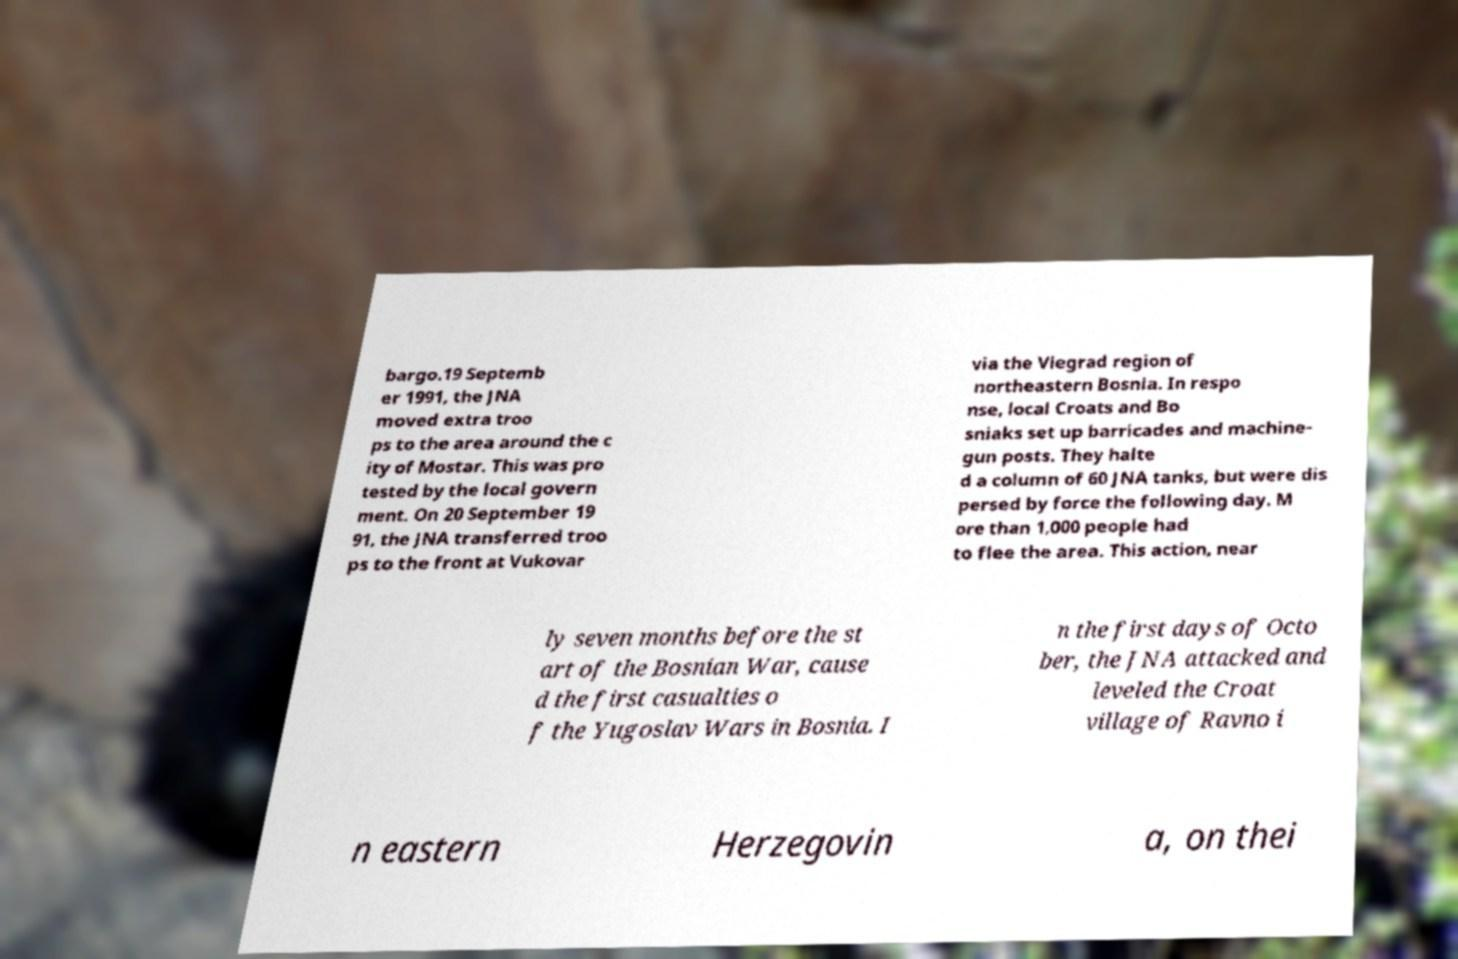Can you read and provide the text displayed in the image?This photo seems to have some interesting text. Can you extract and type it out for me? bargo.19 Septemb er 1991, the JNA moved extra troo ps to the area around the c ity of Mostar. This was pro tested by the local govern ment. On 20 September 19 91, the JNA transferred troo ps to the front at Vukovar via the Viegrad region of northeastern Bosnia. In respo nse, local Croats and Bo sniaks set up barricades and machine- gun posts. They halte d a column of 60 JNA tanks, but were dis persed by force the following day. M ore than 1,000 people had to flee the area. This action, near ly seven months before the st art of the Bosnian War, cause d the first casualties o f the Yugoslav Wars in Bosnia. I n the first days of Octo ber, the JNA attacked and leveled the Croat village of Ravno i n eastern Herzegovin a, on thei 